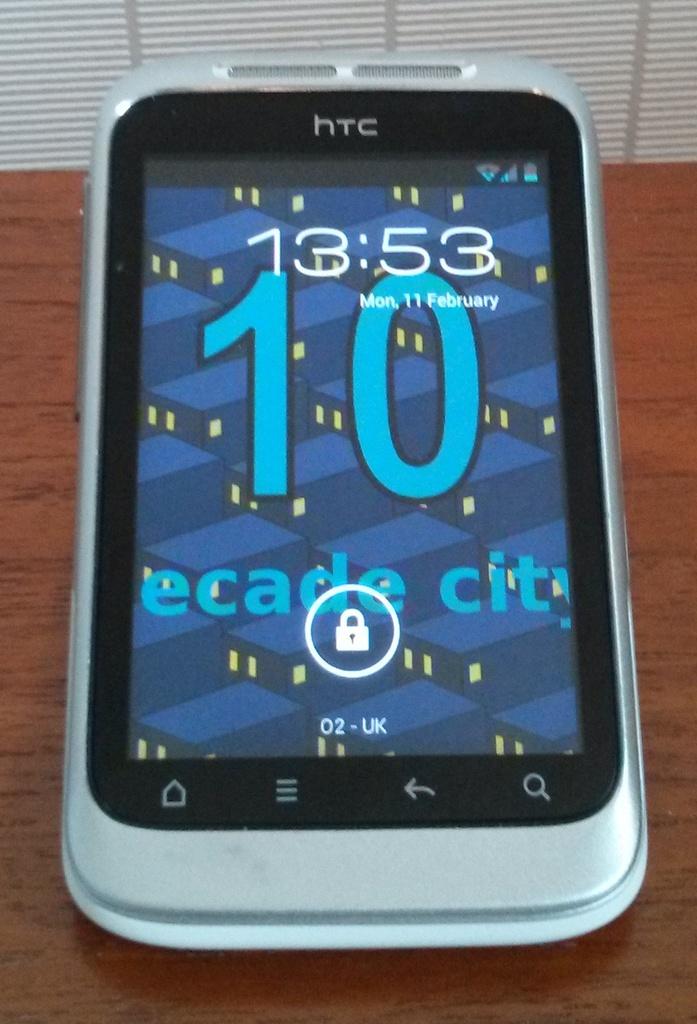What time does this phone state?
Give a very brief answer. 13:53. What us the number displayed on the screen?
Give a very brief answer. 10. 